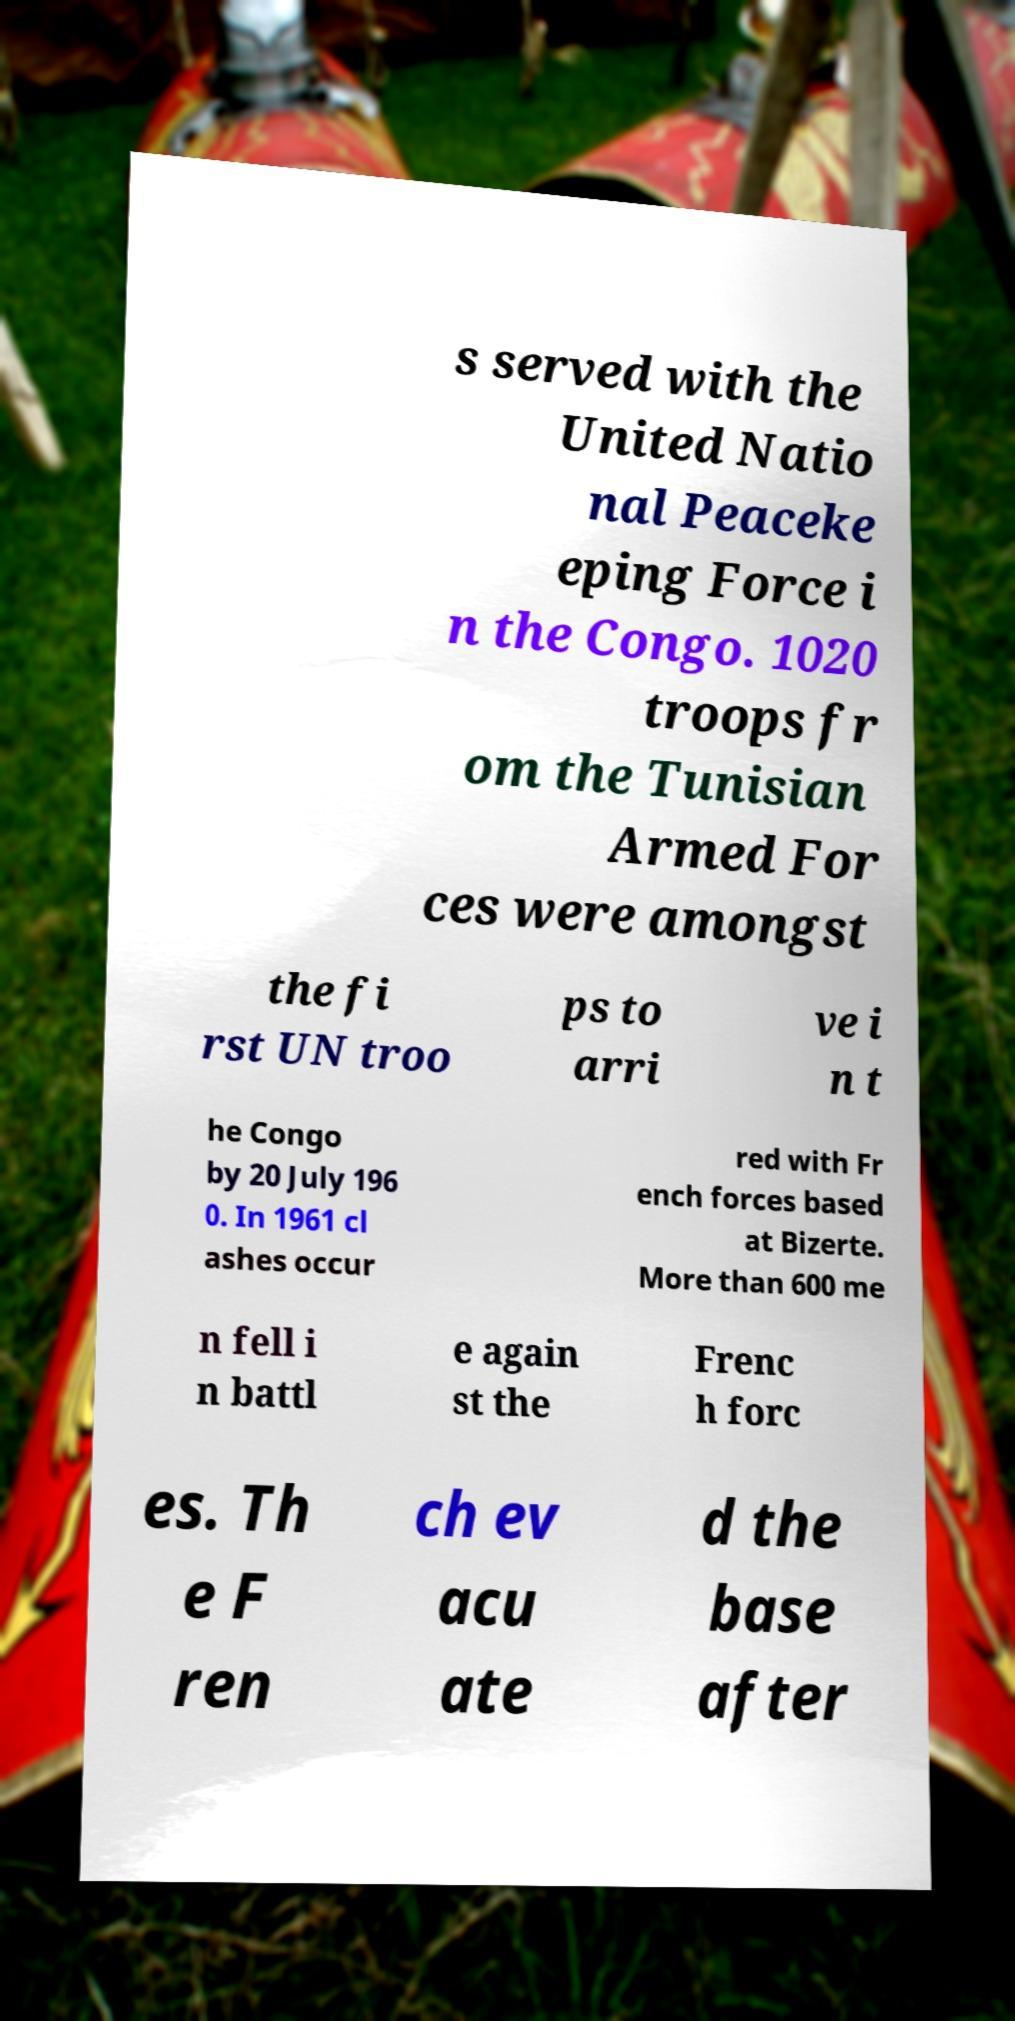For documentation purposes, I need the text within this image transcribed. Could you provide that? s served with the United Natio nal Peaceke eping Force i n the Congo. 1020 troops fr om the Tunisian Armed For ces were amongst the fi rst UN troo ps to arri ve i n t he Congo by 20 July 196 0. In 1961 cl ashes occur red with Fr ench forces based at Bizerte. More than 600 me n fell i n battl e again st the Frenc h forc es. Th e F ren ch ev acu ate d the base after 